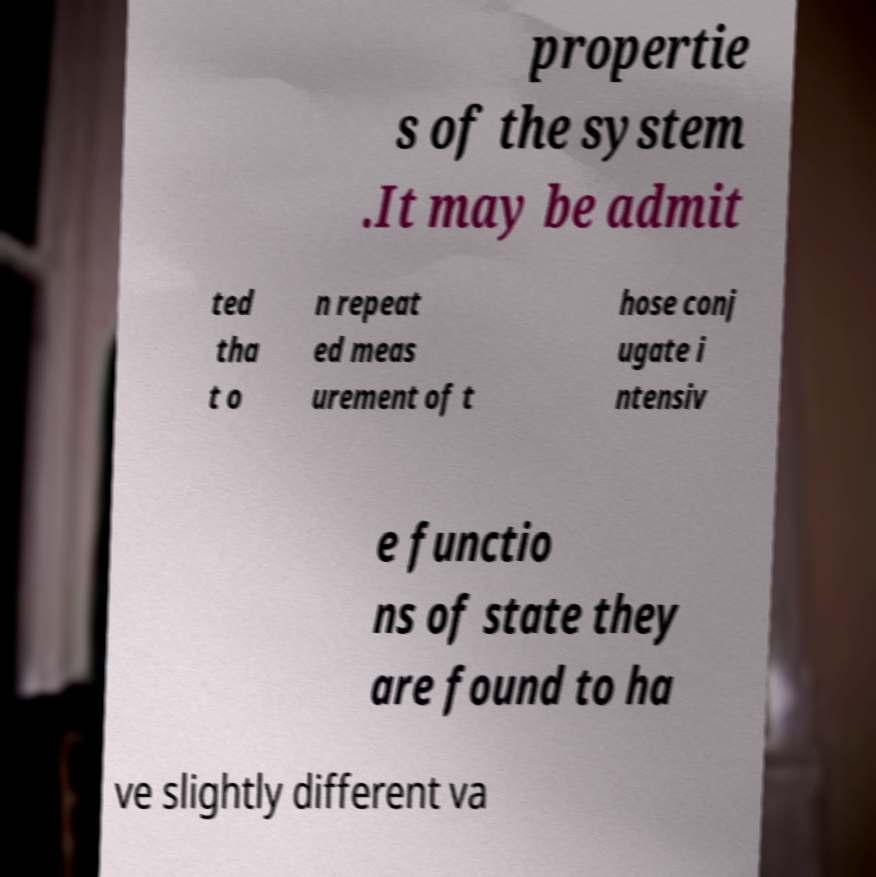Can you accurately transcribe the text from the provided image for me? propertie s of the system .It may be admit ted tha t o n repeat ed meas urement of t hose conj ugate i ntensiv e functio ns of state they are found to ha ve slightly different va 